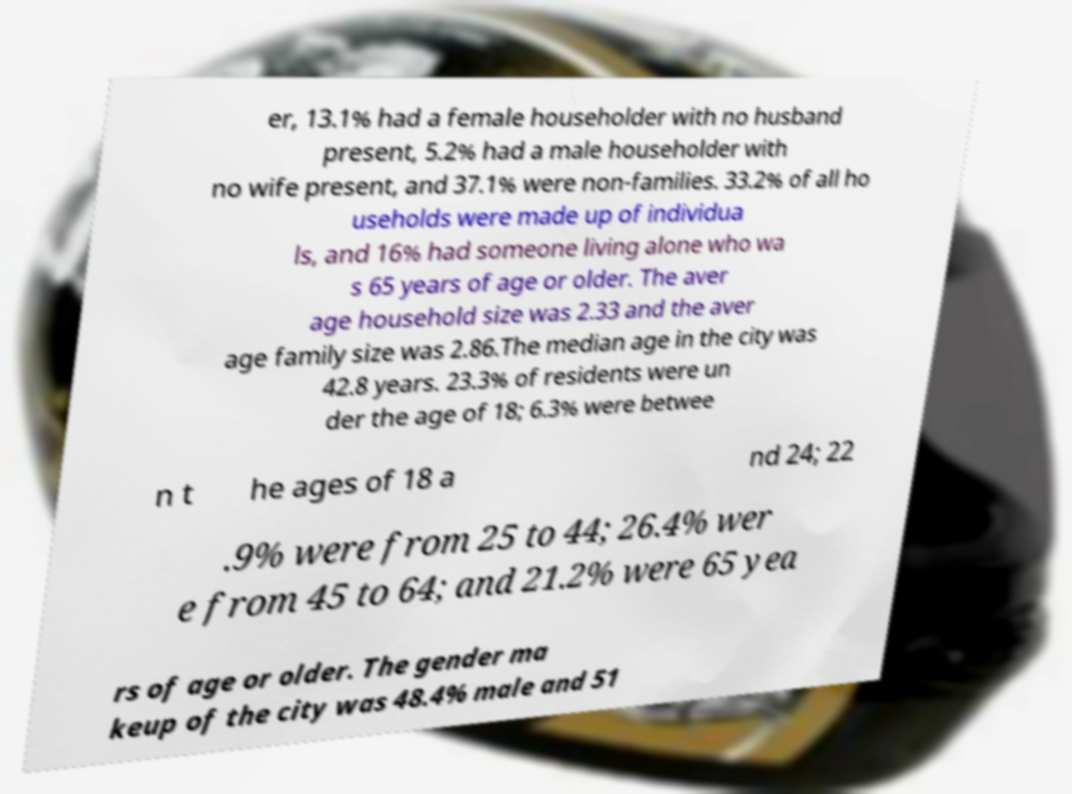What messages or text are displayed in this image? I need them in a readable, typed format. er, 13.1% had a female householder with no husband present, 5.2% had a male householder with no wife present, and 37.1% were non-families. 33.2% of all ho useholds were made up of individua ls, and 16% had someone living alone who wa s 65 years of age or older. The aver age household size was 2.33 and the aver age family size was 2.86.The median age in the city was 42.8 years. 23.3% of residents were un der the age of 18; 6.3% were betwee n t he ages of 18 a nd 24; 22 .9% were from 25 to 44; 26.4% wer e from 45 to 64; and 21.2% were 65 yea rs of age or older. The gender ma keup of the city was 48.4% male and 51 